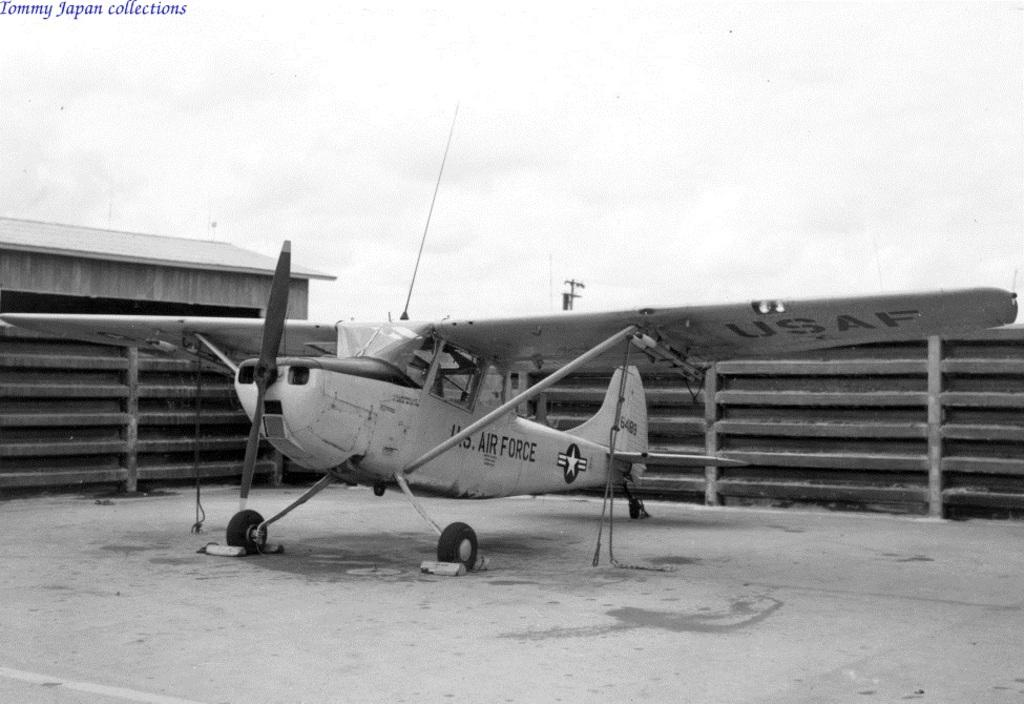<image>
Write a terse but informative summary of the picture. a US Air Force propeller plane inside a fenced area 